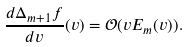Convert formula to latex. <formula><loc_0><loc_0><loc_500><loc_500>\frac { d \Delta _ { m + 1 } f } { d v } ( v ) = \mathcal { O } ( v E _ { m } ( v ) ) .</formula> 